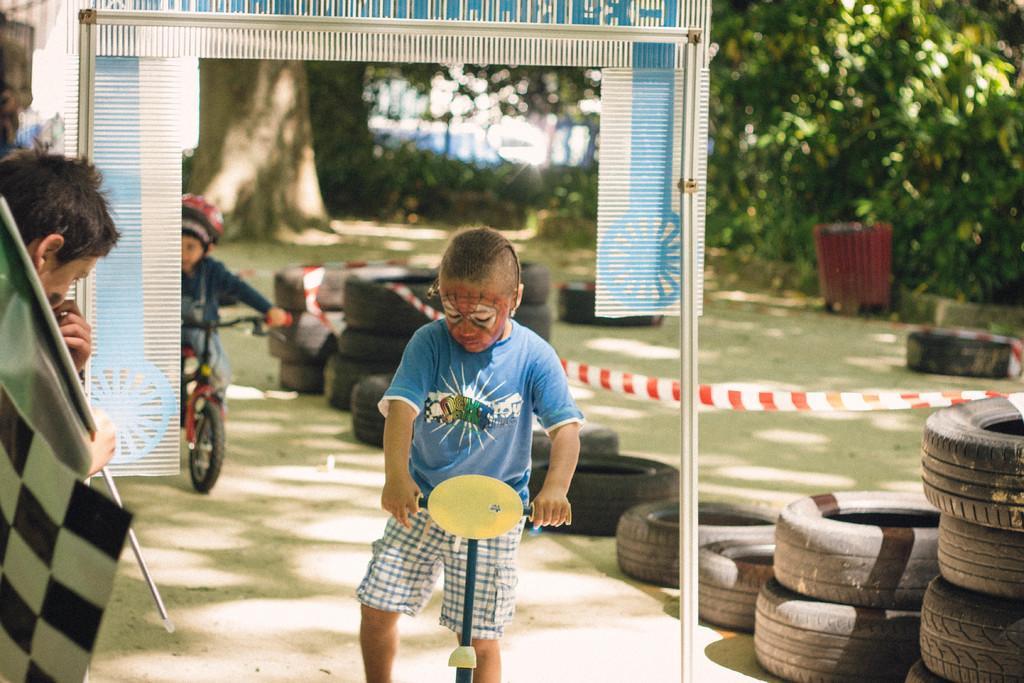Please provide a concise description of this image. In the center of the image we can see a kid is standing and he is holding some object and we can see some paint on his face. On the left side of the image, we can see a person is holding some object. In the background there is an arch, trees, tires, one person is riding a cycle and a few other objects. 